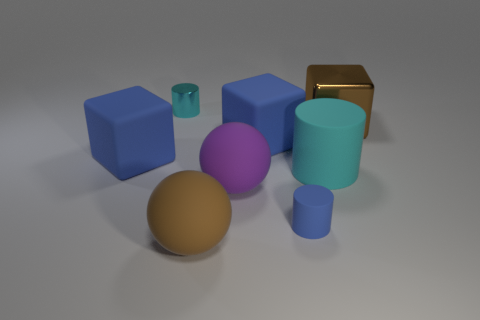What shapes and colors are present in the arrangement shown here? The image displays a collection of geometric shapes including cubes, cylinders, and a sphere. Their colors range from blue, purple, and beige to a shiny metallic tone.  Which object stands out the most and why? The shiny golden cube stands out the most due to its reflective surface and distinct color, drawing the eye amidst the matte textures of the other objects. 